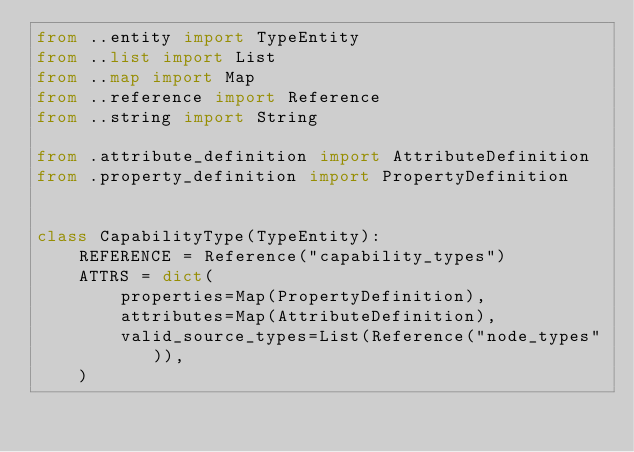<code> <loc_0><loc_0><loc_500><loc_500><_Python_>from ..entity import TypeEntity
from ..list import List
from ..map import Map
from ..reference import Reference
from ..string import String

from .attribute_definition import AttributeDefinition
from .property_definition import PropertyDefinition


class CapabilityType(TypeEntity):
    REFERENCE = Reference("capability_types")
    ATTRS = dict(
        properties=Map(PropertyDefinition),
        attributes=Map(AttributeDefinition),
        valid_source_types=List(Reference("node_types")),
    )
</code> 